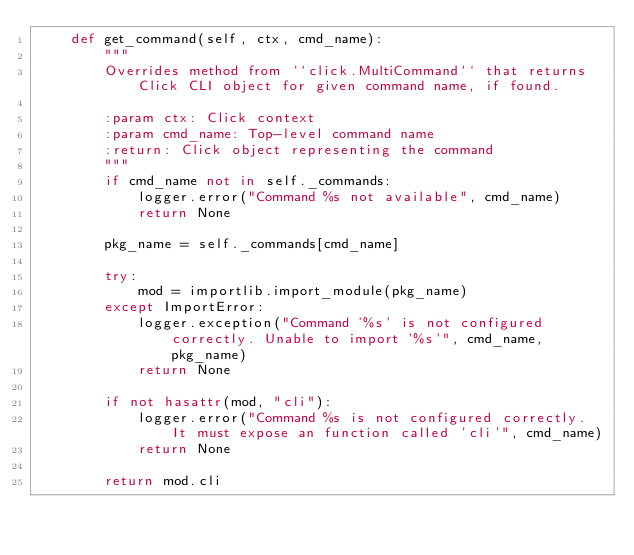Convert code to text. <code><loc_0><loc_0><loc_500><loc_500><_Python_>    def get_command(self, ctx, cmd_name):
        """
        Overrides method from ``click.MultiCommand`` that returns Click CLI object for given command name, if found.

        :param ctx: Click context
        :param cmd_name: Top-level command name
        :return: Click object representing the command
        """
        if cmd_name not in self._commands:
            logger.error("Command %s not available", cmd_name)
            return None

        pkg_name = self._commands[cmd_name]

        try:
            mod = importlib.import_module(pkg_name)
        except ImportError:
            logger.exception("Command '%s' is not configured correctly. Unable to import '%s'", cmd_name, pkg_name)
            return None

        if not hasattr(mod, "cli"):
            logger.error("Command %s is not configured correctly. It must expose an function called 'cli'", cmd_name)
            return None

        return mod.cli
</code> 